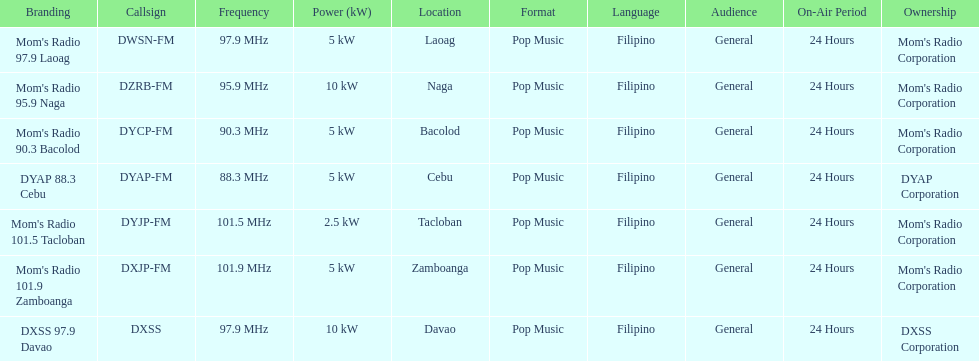What are the total number of radio stations on this list? 7. 